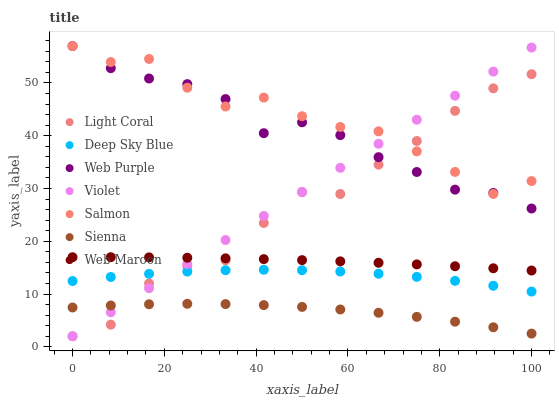Does Sienna have the minimum area under the curve?
Answer yes or no. Yes. Does Salmon have the maximum area under the curve?
Answer yes or no. Yes. Does Web Maroon have the minimum area under the curve?
Answer yes or no. No. Does Web Maroon have the maximum area under the curve?
Answer yes or no. No. Is Violet the smoothest?
Answer yes or no. Yes. Is Light Coral the roughest?
Answer yes or no. Yes. Is Web Maroon the smoothest?
Answer yes or no. No. Is Web Maroon the roughest?
Answer yes or no. No. Does Light Coral have the lowest value?
Answer yes or no. Yes. Does Web Maroon have the lowest value?
Answer yes or no. No. Does Web Purple have the highest value?
Answer yes or no. Yes. Does Web Maroon have the highest value?
Answer yes or no. No. Is Web Maroon less than Web Purple?
Answer yes or no. Yes. Is Salmon greater than Deep Sky Blue?
Answer yes or no. Yes. Does Sienna intersect Light Coral?
Answer yes or no. Yes. Is Sienna less than Light Coral?
Answer yes or no. No. Is Sienna greater than Light Coral?
Answer yes or no. No. Does Web Maroon intersect Web Purple?
Answer yes or no. No. 